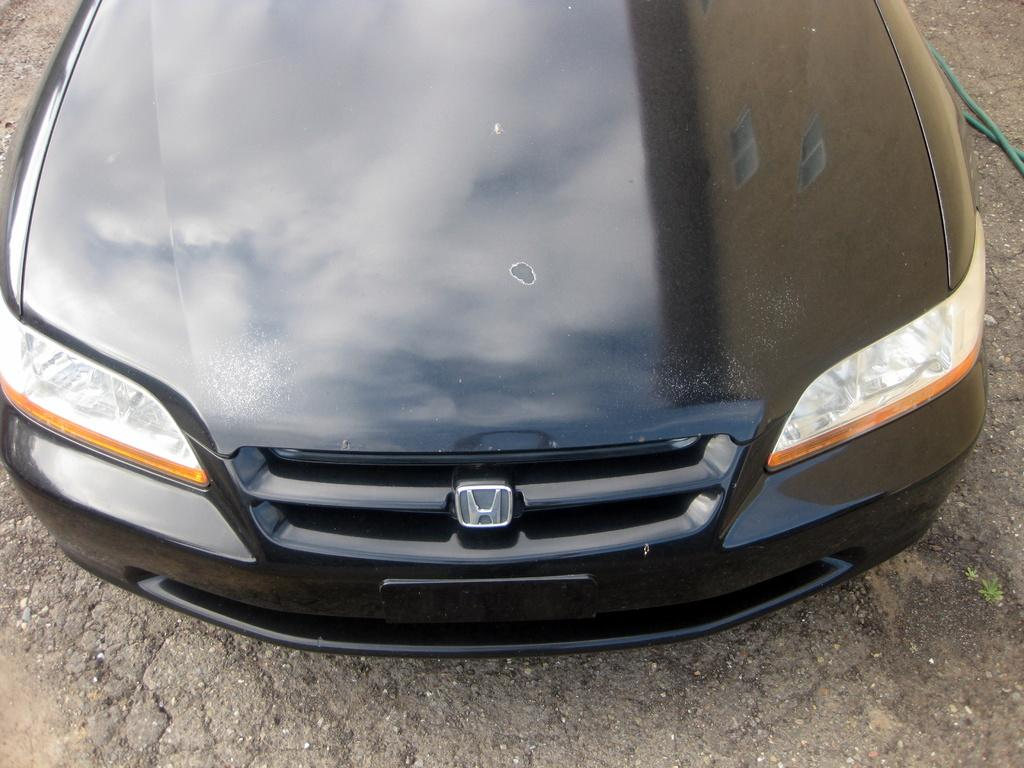What part of a vehicle can be seen in the image? The bonnet of a car is visible in the image. What type of silk is being used by the maid in the image? There is no maid or silk present in the image; it only features the bonnet of a car. 